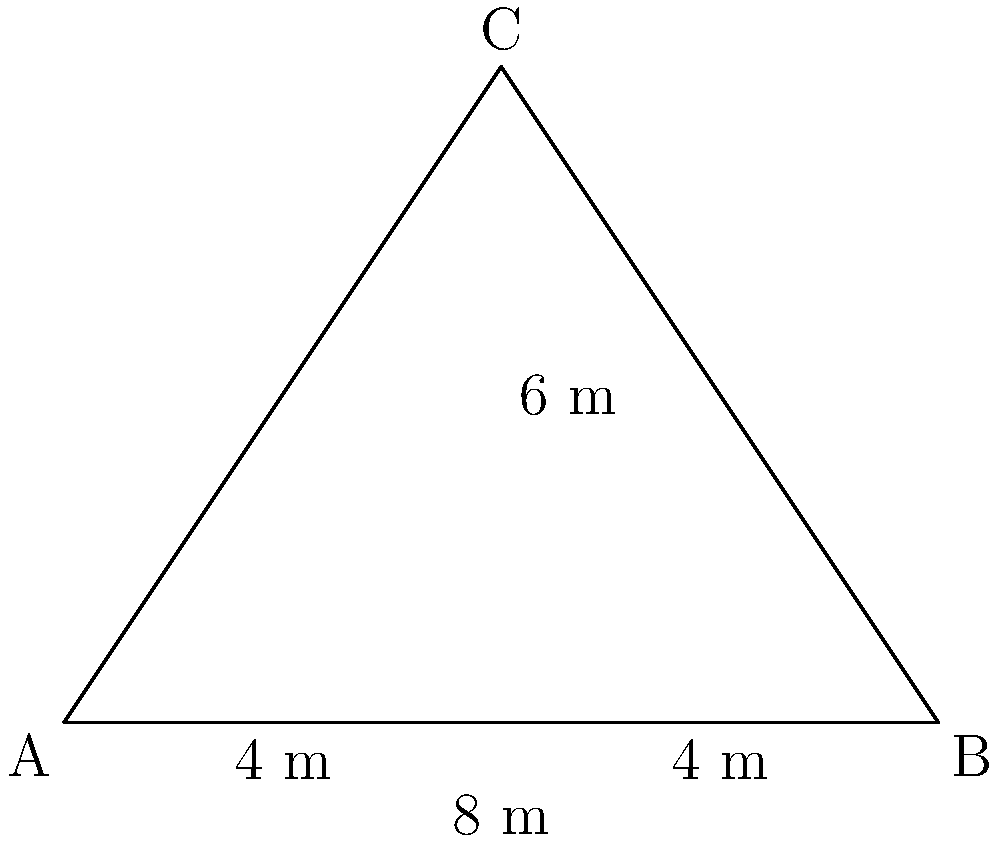A triangular buffer zone is established between a logging road and a protected waterway. The base of the triangle (along the road) measures 8 meters, and the perpendicular distance from the road to the waterway is 6 meters. What is the area of this buffer zone in square meters? To find the area of the triangular buffer zone, we can use the formula for the area of a triangle:

$$A = \frac{1}{2} \times base \times height$$

Given:
- Base (along the road) = 8 meters
- Height (perpendicular distance to the waterway) = 6 meters

Step 1: Plug the values into the formula
$$A = \frac{1}{2} \times 8 \times 6$$

Step 2: Multiply
$$A = \frac{1}{2} \times 48$$

Step 3: Simplify
$$A = 24$$

Therefore, the area of the triangular buffer zone is 24 square meters.
Answer: 24 m² 